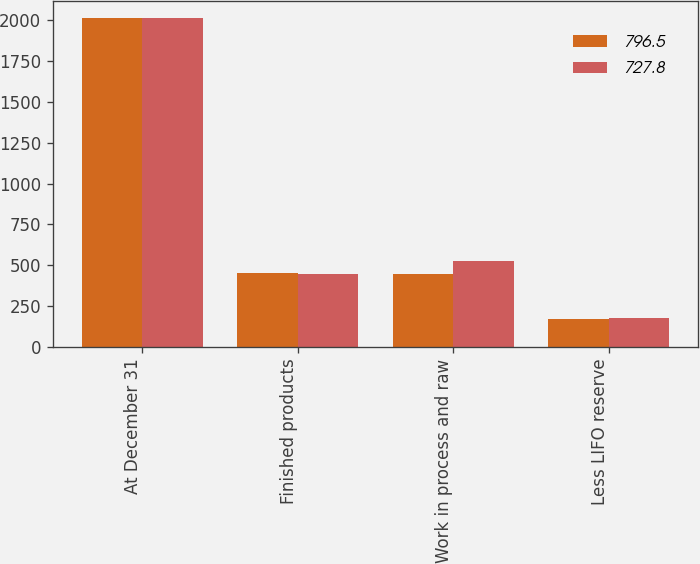Convert chart to OTSL. <chart><loc_0><loc_0><loc_500><loc_500><stacked_bar_chart><ecel><fcel>At December 31<fcel>Finished products<fcel>Work in process and raw<fcel>Less LIFO reserve<nl><fcel>796.5<fcel>2016<fcel>452.3<fcel>444.7<fcel>169.2<nl><fcel>727.8<fcel>2015<fcel>443.6<fcel>528.9<fcel>176<nl></chart> 